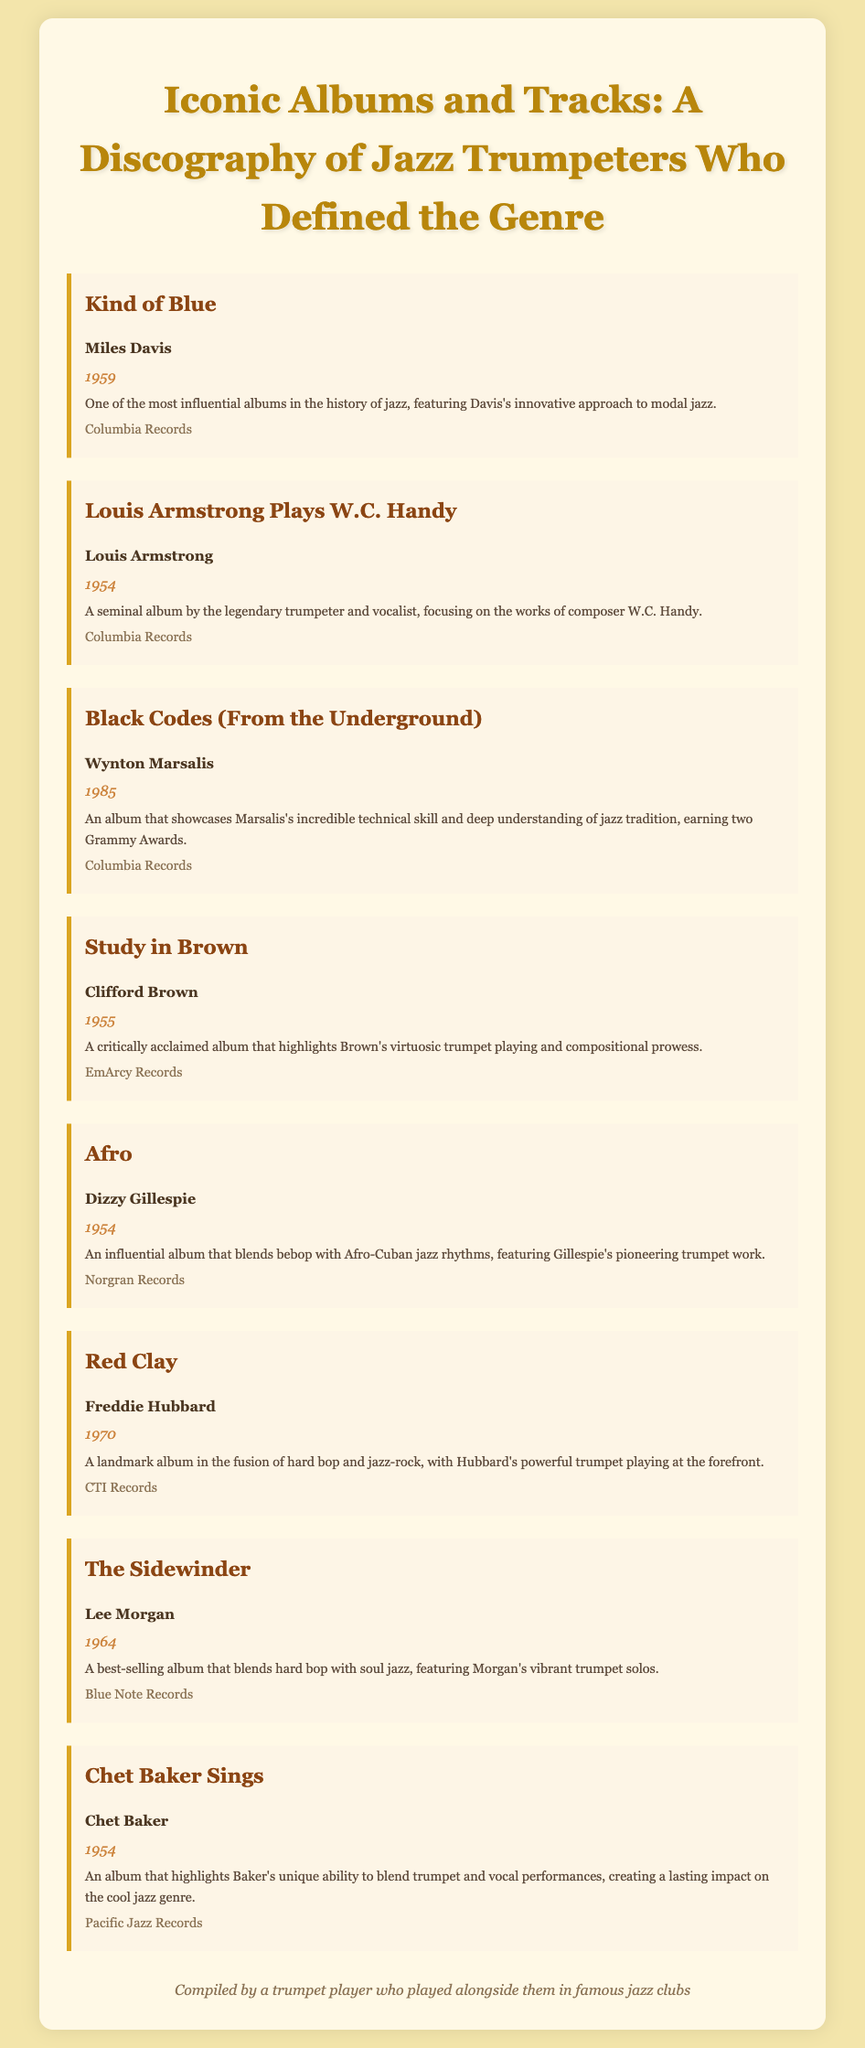what is the title of the album by Miles Davis? The title of the album by Miles Davis is the first bibliographic item listed in the document.
Answer: Kind of Blue which album features W.C. Handy's works? This information is found in the bibliography item that lists Louis Armstrong as the author.
Answer: Louis Armstrong Plays W.C. Handy who is the author of the album "Study in Brown"? The author's name is provided under the bibliographic entry for this album.
Answer: Clifford Brown in what year was "Red Clay" released? The release year is stated directly below the title for the album "Red Clay."
Answer: 1970 which album showcases Wynton Marsalis's technical skill? The description of the album directly highlights Wynton Marsalis's skills.
Answer: Black Codes (From the Underground) how many Grammy Awards did Wynton Marsalis's album win? The number of Grammy Awards won is mentioned in the description of the album's entry.
Answer: Two which record label released Chet Baker Sings? The record label is provided in the bibliography entry for this particular album.
Answer: Pacific Jazz Records who is known for pioneering trumpet work blending bebop and Afro-Cuban jazz? This information comes from the description under Dizzy Gillespie's album entry.
Answer: Dizzy Gillespie 